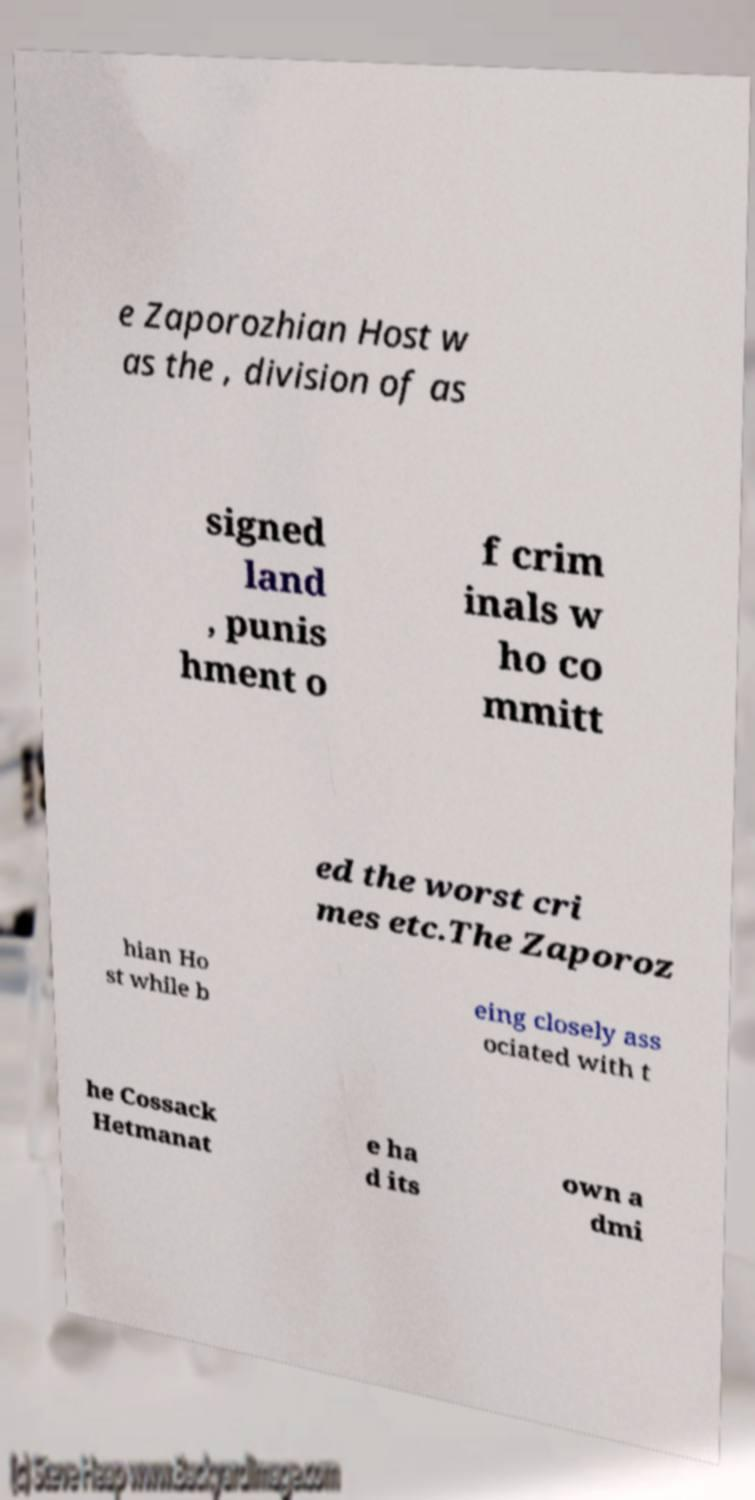Can you accurately transcribe the text from the provided image for me? e Zaporozhian Host w as the , division of as signed land , punis hment o f crim inals w ho co mmitt ed the worst cri mes etc.The Zaporoz hian Ho st while b eing closely ass ociated with t he Cossack Hetmanat e ha d its own a dmi 